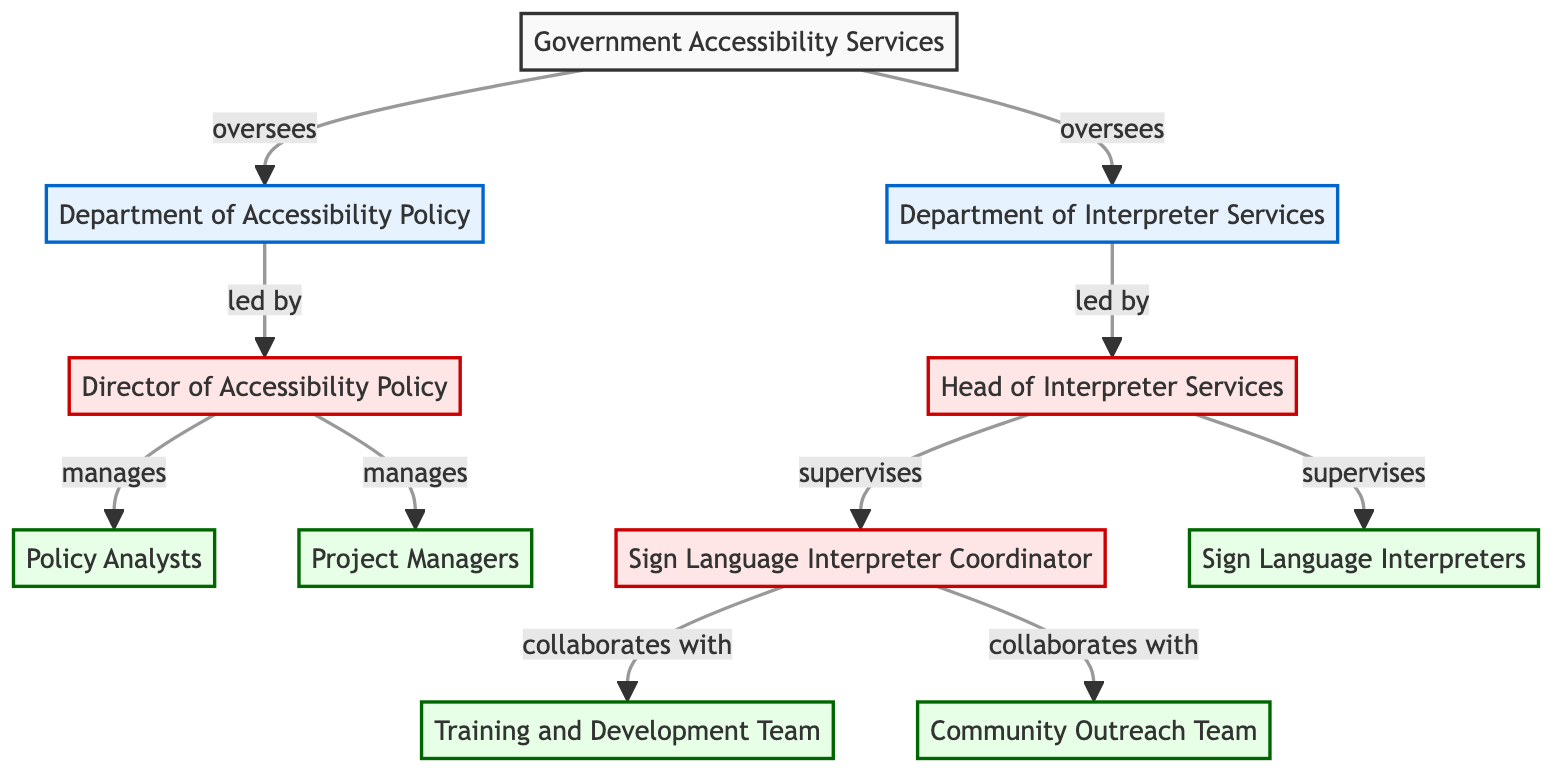What is the top-level node in the diagram? The diagram starts with "Government Accessibility Services" as the top-level node. This is the main entity overseeing the organization depicted in the chart.
Answer: Government Accessibility Services Which department is led by the Director of Accessibility Policy? The "Department of Accessibility Policy" is led by the "Director of Accessibility Policy." This is explicitly indicated by the connection and titles in the diagram.
Answer: Department of Accessibility Policy How many teams are directly under the Sign Language Interpreter Coordinator? The "Sign Language Interpreter Coordinator" directly collaborates with two teams: "Training and Development Team" and "Community Outreach Team." This information is derived from the connections shown in the diagram.
Answer: 2 Who oversees the Department of Interpreter Services? The "Department of Interpreter Services" is overseen by the "Government Accessibility Services." According to the diagram, the relationship is one of oversight.
Answer: Government Accessibility Services Which role supervises the Sign Language Interpreters? The "Head of Interpreter Services" supervises the "Sign Language Interpreters." The diagram clearly indicates this relationship.
Answer: Head of Interpreter Services What are the two main groups collaborated with by the Sign Language Interpreter Coordinator? The "Sign Language Interpreter Coordinator" collaborates with the "Training and Development Team" and the "Community Outreach Team." These collaborations are explicitly shown in the diagram as connections.
Answer: Training and Development Team, Community Outreach Team What is the relationship between the Policy Analysts and the Director of Accessibility Policy? The "Policy Analysts" are managed by the "Director of Accessibility Policy." This relationship is outlined in the diagram, indicating a direct supervisory link.
Answer: managed by How many nodes are present in the diagram? The diagram consists of eleven nodes that represent various departments, roles, and teams involved in accessibility services. This is counted by identifying each unique element in the chart.
Answer: 11 Which department has both project managers and policy analysts? The "Department of Accessibility Policy" has both "Project Managers" and "Policy Analysts" managed by the "Director of Accessibility Policy," as indicated by their positions in the diagram.
Answer: Department of Accessibility Policy 